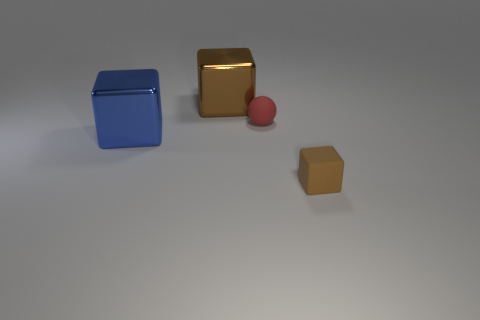Add 4 large rubber blocks. How many objects exist? 8 Subtract all cubes. How many objects are left? 1 Add 3 big blue shiny cubes. How many big blue shiny cubes exist? 4 Subtract 0 purple balls. How many objects are left? 4 Subtract all large brown metal objects. Subtract all tiny red metallic objects. How many objects are left? 3 Add 1 big cubes. How many big cubes are left? 3 